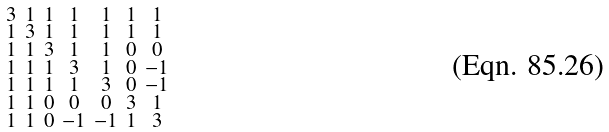Convert formula to latex. <formula><loc_0><loc_0><loc_500><loc_500>\begin{smallmatrix} 3 & 1 & 1 & 1 & 1 & 1 & 1 \\ 1 & 3 & 1 & 1 & 1 & 1 & 1 \\ 1 & 1 & 3 & 1 & 1 & 0 & 0 \\ 1 & 1 & 1 & 3 & 1 & 0 & - 1 \\ 1 & 1 & 1 & 1 & 3 & 0 & - 1 \\ 1 & 1 & 0 & 0 & 0 & 3 & 1 \\ 1 & 1 & 0 & - 1 & - 1 & 1 & 3 \end{smallmatrix}</formula> 